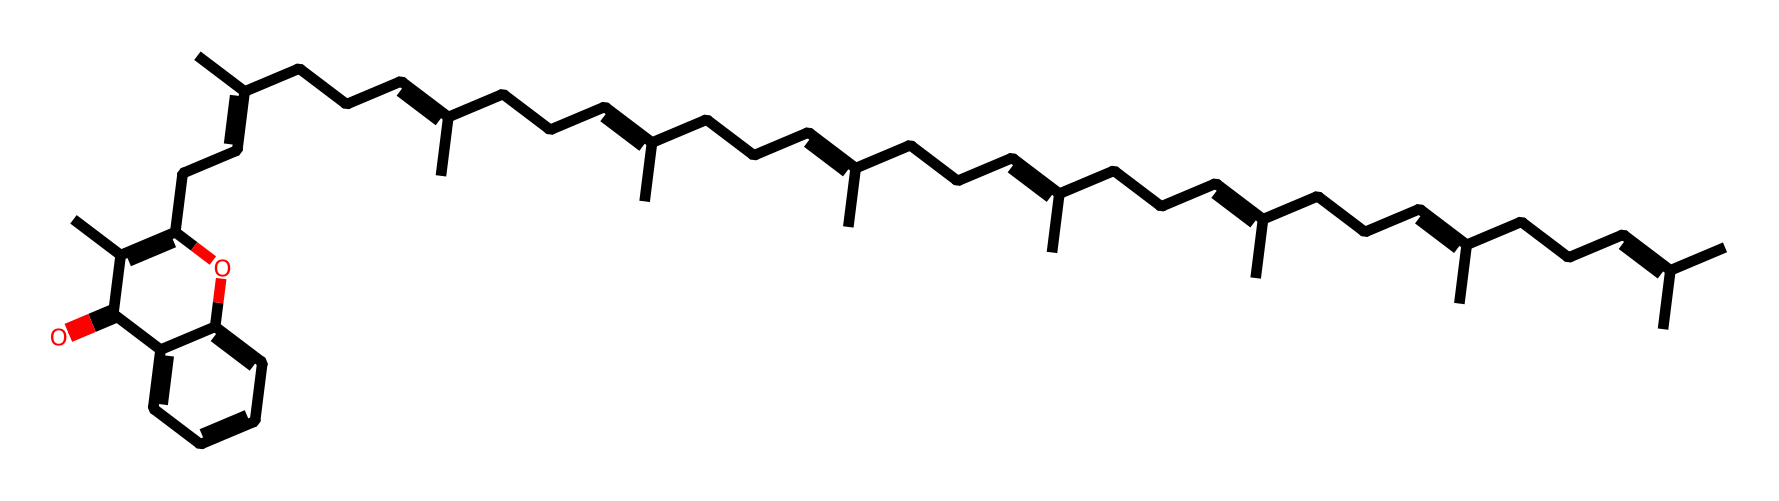What is the main functional group present in vitamin K2? The SMILES representation contains a carbonyl (C=O) functional group, which is characterized by the presence of a carbon atom double-bonded to an oxygen atom. This is typically found in ketones or aldehydes, and in this structure, it is part of a ring system.
Answer: carbonyl How many double bonds are present in the structure of vitamin K2? By examining the SMILES structure, one can identify several segments with the notation 'C=C,' indicating double bonds between carbon atoms. Counting these reveals a total of 8 double bonds in the structure.
Answer: 8 What type of vitamin is represented by this chemical structure? The structure matches the known characteristics of vitamin K, specifically vitamin K2 (menaquinone), which is recognized for its role in blood coagulation and bone health.
Answer: vitamin K2 Which parts of the structure contribute to the lipophilic nature of vitamin K2? The long carbon chains (alkyl groups) present in the structure enhance its lipophilicity, making it soluble in fats and oils, which is typical for fat-soluble vitamins like K2.
Answer: long carbon chains What is the total number of carbon atoms in the vitamin K2 structure? By analyzing the chemical structure represented in the SMILES notation, one can count the number of carbon atoms listed and derive that there are 29 carbon atoms in total.
Answer: 29 